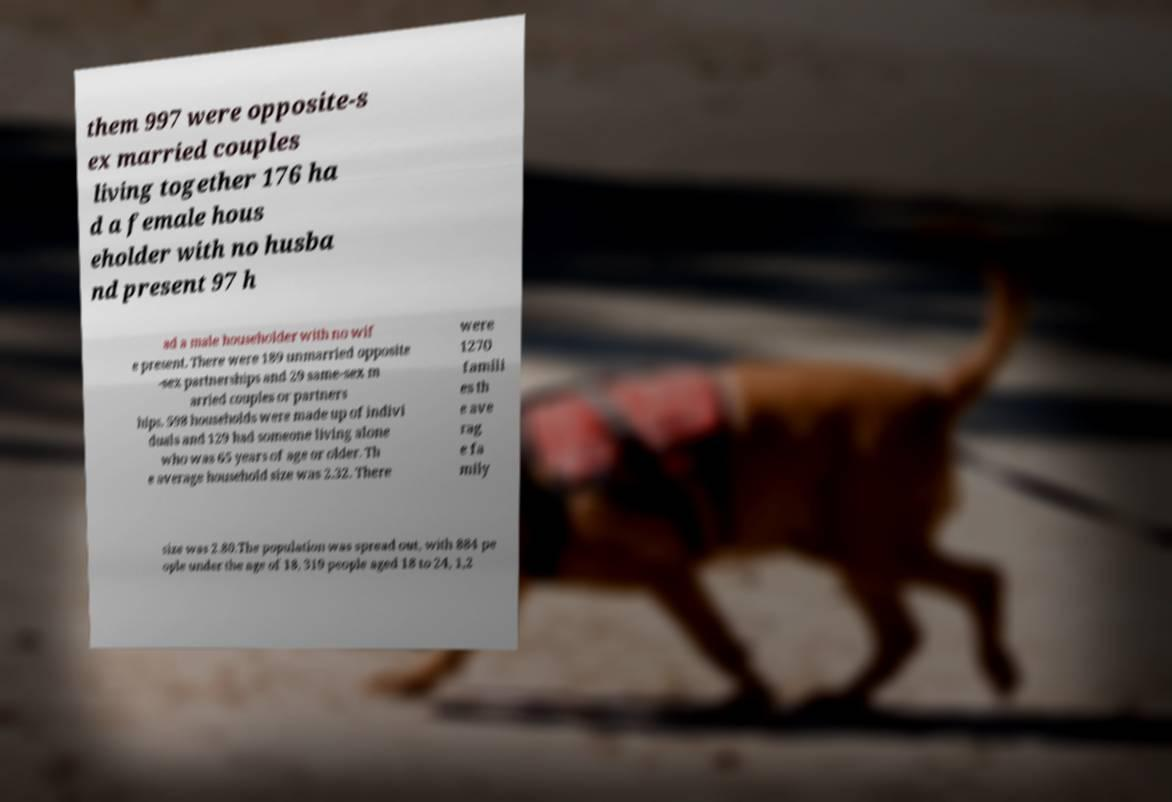I need the written content from this picture converted into text. Can you do that? them 997 were opposite-s ex married couples living together 176 ha d a female hous eholder with no husba nd present 97 h ad a male householder with no wif e present. There were 189 unmarried opposite -sex partnerships and 29 same-sex m arried couples or partners hips. 598 households were made up of indivi duals and 129 had someone living alone who was 65 years of age or older. Th e average household size was 2.32. There were 1270 famili es th e ave rag e fa mily size was 2.80.The population was spread out, with 884 pe ople under the age of 18, 319 people aged 18 to 24, 1,2 